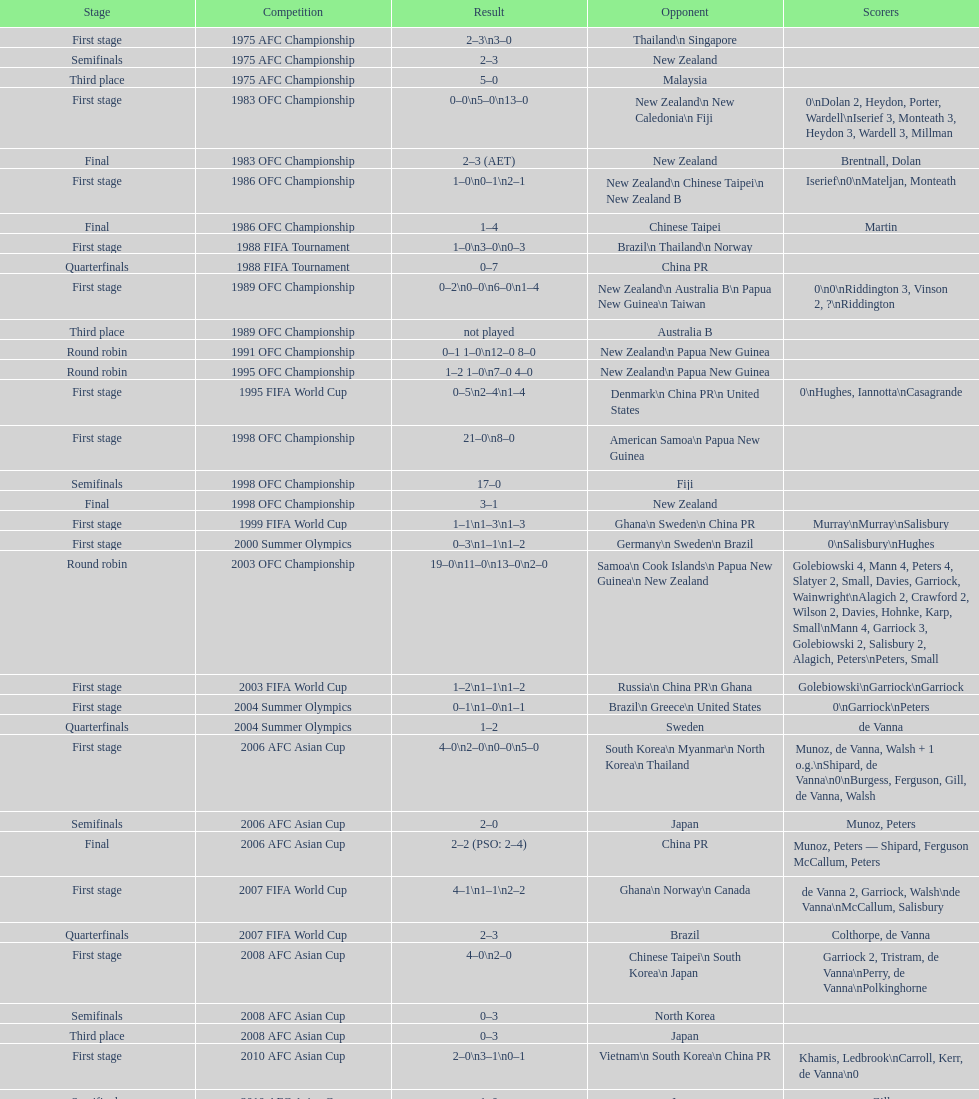What it the total number of countries in the first stage of the 2008 afc asian cup? 4. 